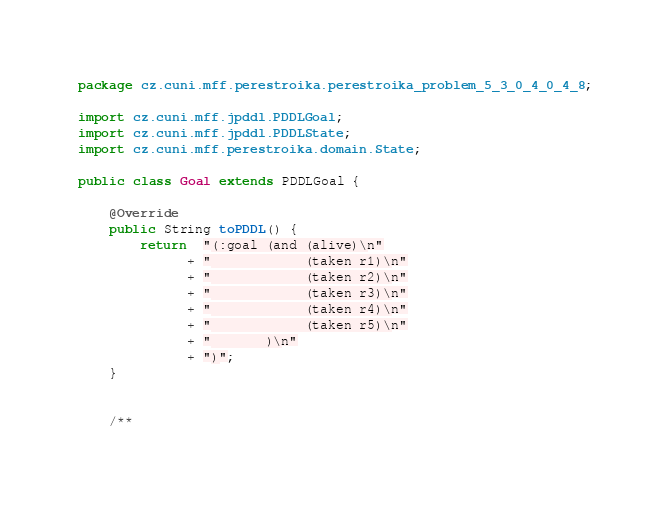Convert code to text. <code><loc_0><loc_0><loc_500><loc_500><_Java_>package cz.cuni.mff.perestroika.perestroika_problem_5_3_0_4_0_4_8;

import cz.cuni.mff.jpddl.PDDLGoal;
import cz.cuni.mff.jpddl.PDDLState;
import cz.cuni.mff.perestroika.domain.State;

public class Goal extends PDDLGoal {
	
	@Override
	public String toPDDL() {
		return  "(:goal (and (alive)\n"
			  + "            (taken r1)\n"			
			  + "            (taken r2)\n"			
			  + "            (taken r3)\n"			
			  + "            (taken r4)\n"			
			  + "            (taken r5)\n"			
			  + "       )\n"
			  + ")";
	}

	
	/**</code> 